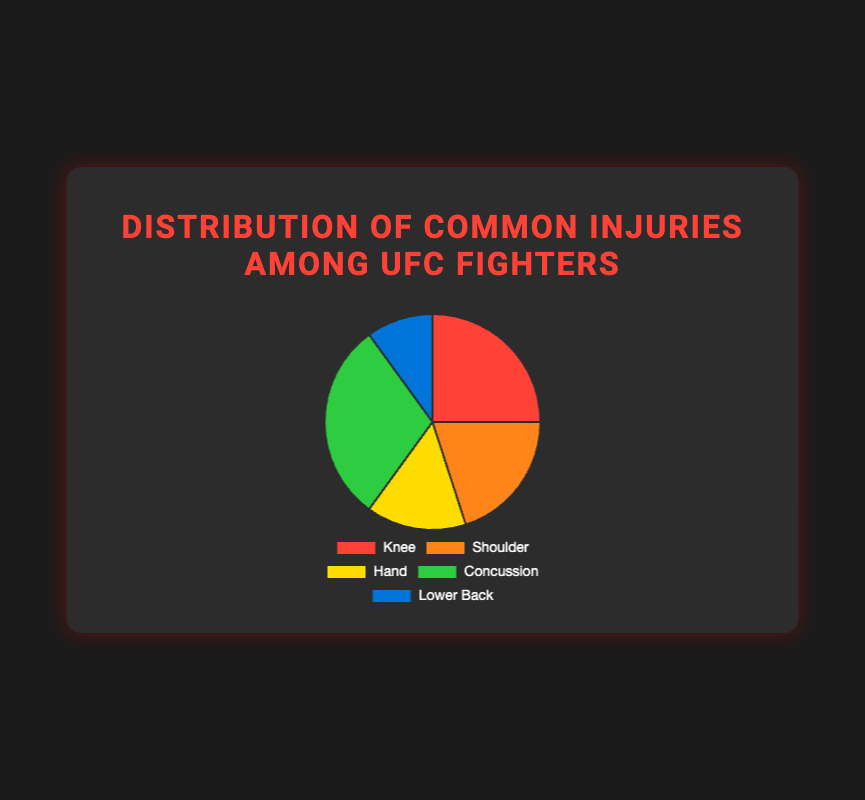Which injury is the most common among UFC fighters? Concussion is the most common injury among UFC fighters, as it represents the largest segment of the pie chart.
Answer: Concussion Which two injuries together make up more than half of all injuries? Adding the percentages for Concussion (30%) and Knee (25%) yields 55%, which is more than half.
Answer: Concussion and Knee What is the difference in the proportion of fighters with knee injuries compared to hand injuries? To find the difference, subtract the percentage of fighters with hand injuries (15%) from those with knee injuries (25%): 25% - 15% = 10%.
Answer: 10% Which injury category is represented in blue? The Lower Back injury category is represented in blue, as indicated by the corresponding color in the pie chart.
Answer: Lower Back What are the three least common injuries among UFC fighters? The three least common injuries are Shoulder (20%), Hand (15%), and Lower Back (10%), as these segments are smaller compared to others.
Answer: Shoulder, Hand, and Lower Back How much more common are concussions compared to lower back injuries? To find out how much more common concussions are compared to lower back injuries, subtract the percentage for Lower Back injuries (10%) from Concussions (30%): 30% - 10% = 20%.
Answer: 20% What proportion of injuries do shoulder and hand injuries together account for? Adding the percentages of shoulder (20%) and hand (15%) injuries, the total comes to 35%.
Answer: 35% Which injury is less common than both knee and shoulder injuries but more common than lower back injuries? Hand injuries, which account for 15%, are less common than knee (25%) and shoulder (20%) injuries but more common than lower back injuries (10%).
Answer: Hand What is the combined percentage of injuries for knee, shoulder, and hand injuries? Adding the percentages of knee (25%), shoulder (20%), and hand (15%) injuries yields a total of 60%.
Answer: 60% What injury category is represented by the largest green segment in the pie chart? The green segment represents Concussions, which is the largest segment at 30%.
Answer: Concussions 